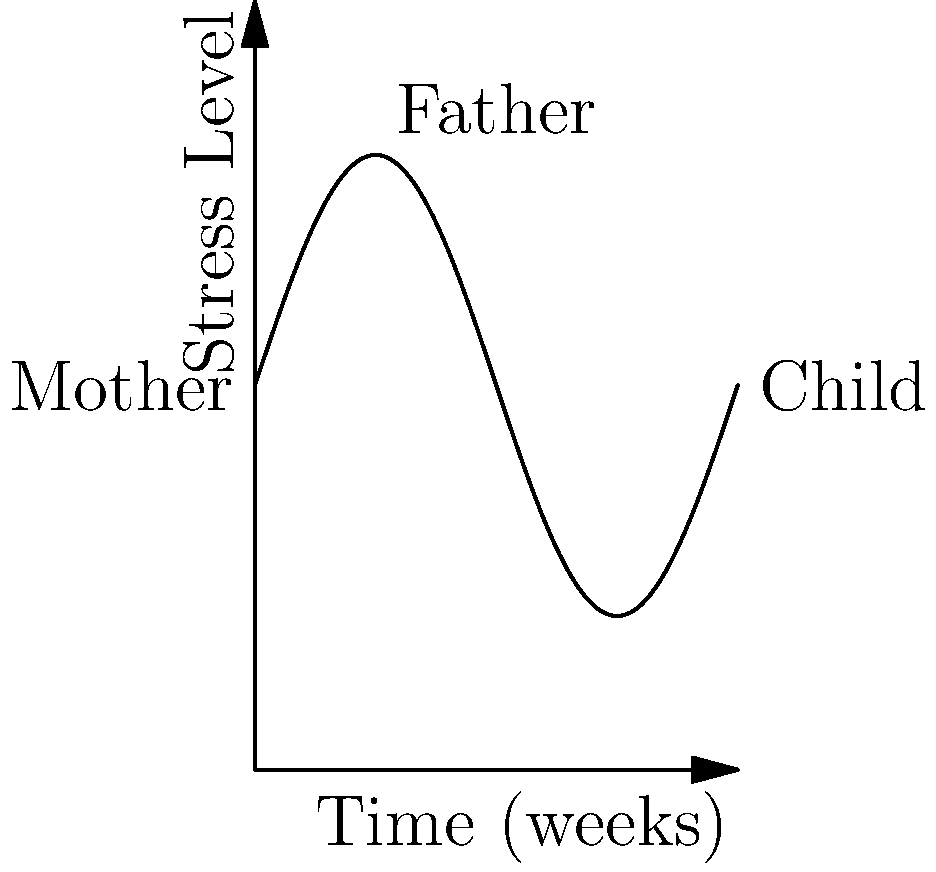A family therapist is monitoring stress levels in a family over an 8-week period. The graph shows the stress levels of the mother, father, and child, represented by the function $f(x) = 5 + 3\sin(x)$, where $x$ is time in weeks and $f(x)$ is the stress level. Calculate the average stress level experienced by the family over this period using the concept of the average value of a function. To find the average stress level, we need to calculate the average value of the function $f(x) = 5 + 3\sin(x)$ over the interval $[0, 2\pi]$ (representing 8 weeks).

Step 1: Recall the formula for the average value of a function:
$$\text{Average Value} = \frac{1}{b-a} \int_{a}^{b} f(x) dx$$

Step 2: Set up the integral:
$$\text{Average Value} = \frac{1}{2\pi - 0} \int_{0}^{2\pi} (5 + 3\sin(x)) dx$$

Step 3: Simplify and evaluate the integral:
$$\text{Average Value} = \frac{1}{2\pi} \left[5x - 3\cos(x)\right]_{0}^{2\pi}$$

Step 4: Substitute the limits:
$$\text{Average Value} = \frac{1}{2\pi} [(5(2\pi) - 3\cos(2\pi)) - (5(0) - 3\cos(0))]$$

Step 5: Simplify:
$$\text{Average Value} = \frac{1}{2\pi} [10\pi - 3 + 3] = \frac{10\pi}{2\pi} = 5$$

Therefore, the average stress level experienced by the family over the 8-week period is 5.
Answer: 5 